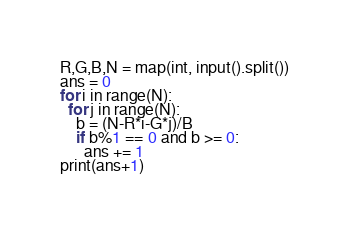<code> <loc_0><loc_0><loc_500><loc_500><_Python_>R,G,B,N = map(int, input().split())
ans = 0
for i in range(N):
  for j in range(N):
    b = (N-R*i-G*j)/B
    if b%1 == 0 and b >= 0:
      ans += 1
print(ans+1)</code> 